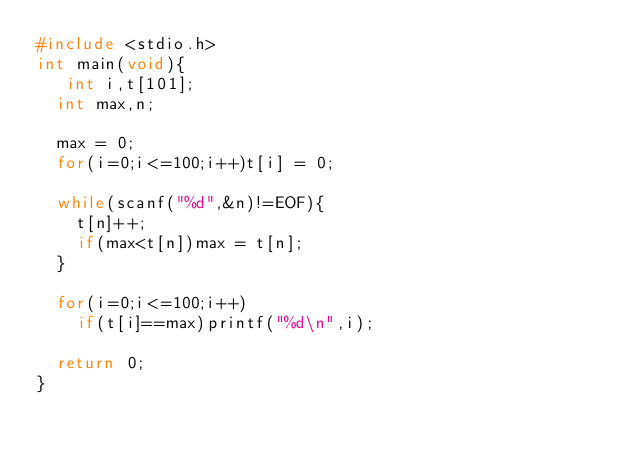<code> <loc_0><loc_0><loc_500><loc_500><_C_>#include <stdio.h>
int main(void){
   int i,t[101];
  int max,n;
 
  max = 0;
  for(i=0;i<=100;i++)t[i] = 0;
 
  while(scanf("%d",&n)!=EOF){
    t[n]++;
    if(max<t[n])max = t[n];
  }
 
  for(i=0;i<=100;i++)
    if(t[i]==max)printf("%d\n",i);
 
  return 0;
}
</code> 